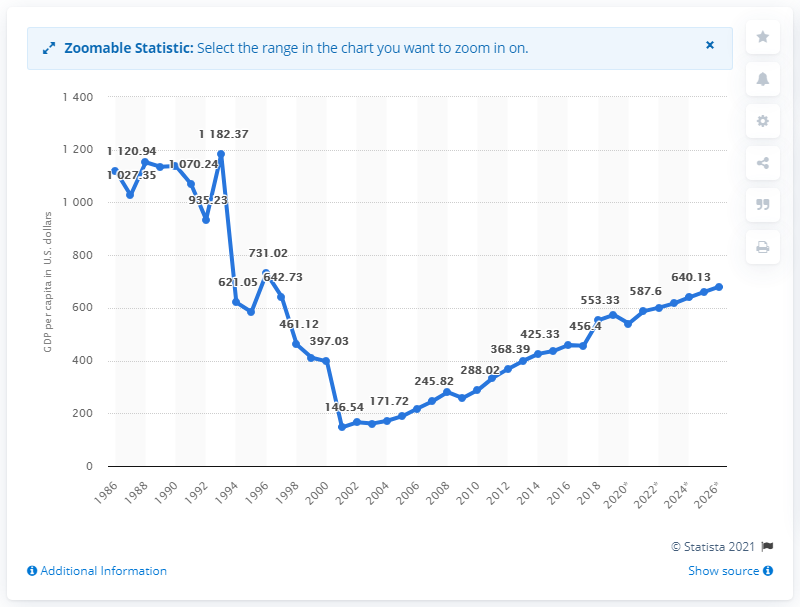Point out several critical features in this image. In 2019, the GDP per capita in the Democratic Republic of the Congo was 573.51. 